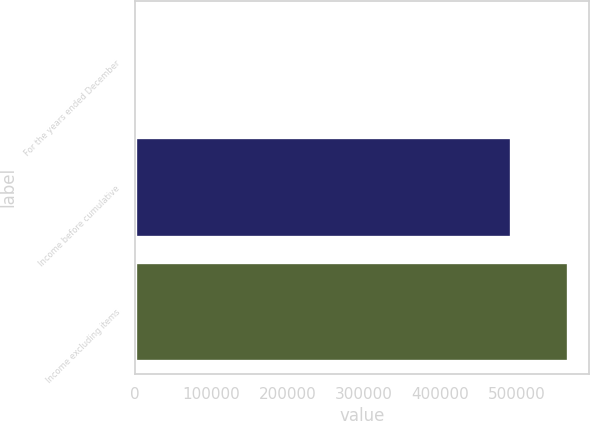Convert chart. <chart><loc_0><loc_0><loc_500><loc_500><bar_chart><fcel>For the years ended December<fcel>Income before cumulative<fcel>Income excluding items<nl><fcel>2005<fcel>493244<fcel>567265<nl></chart> 